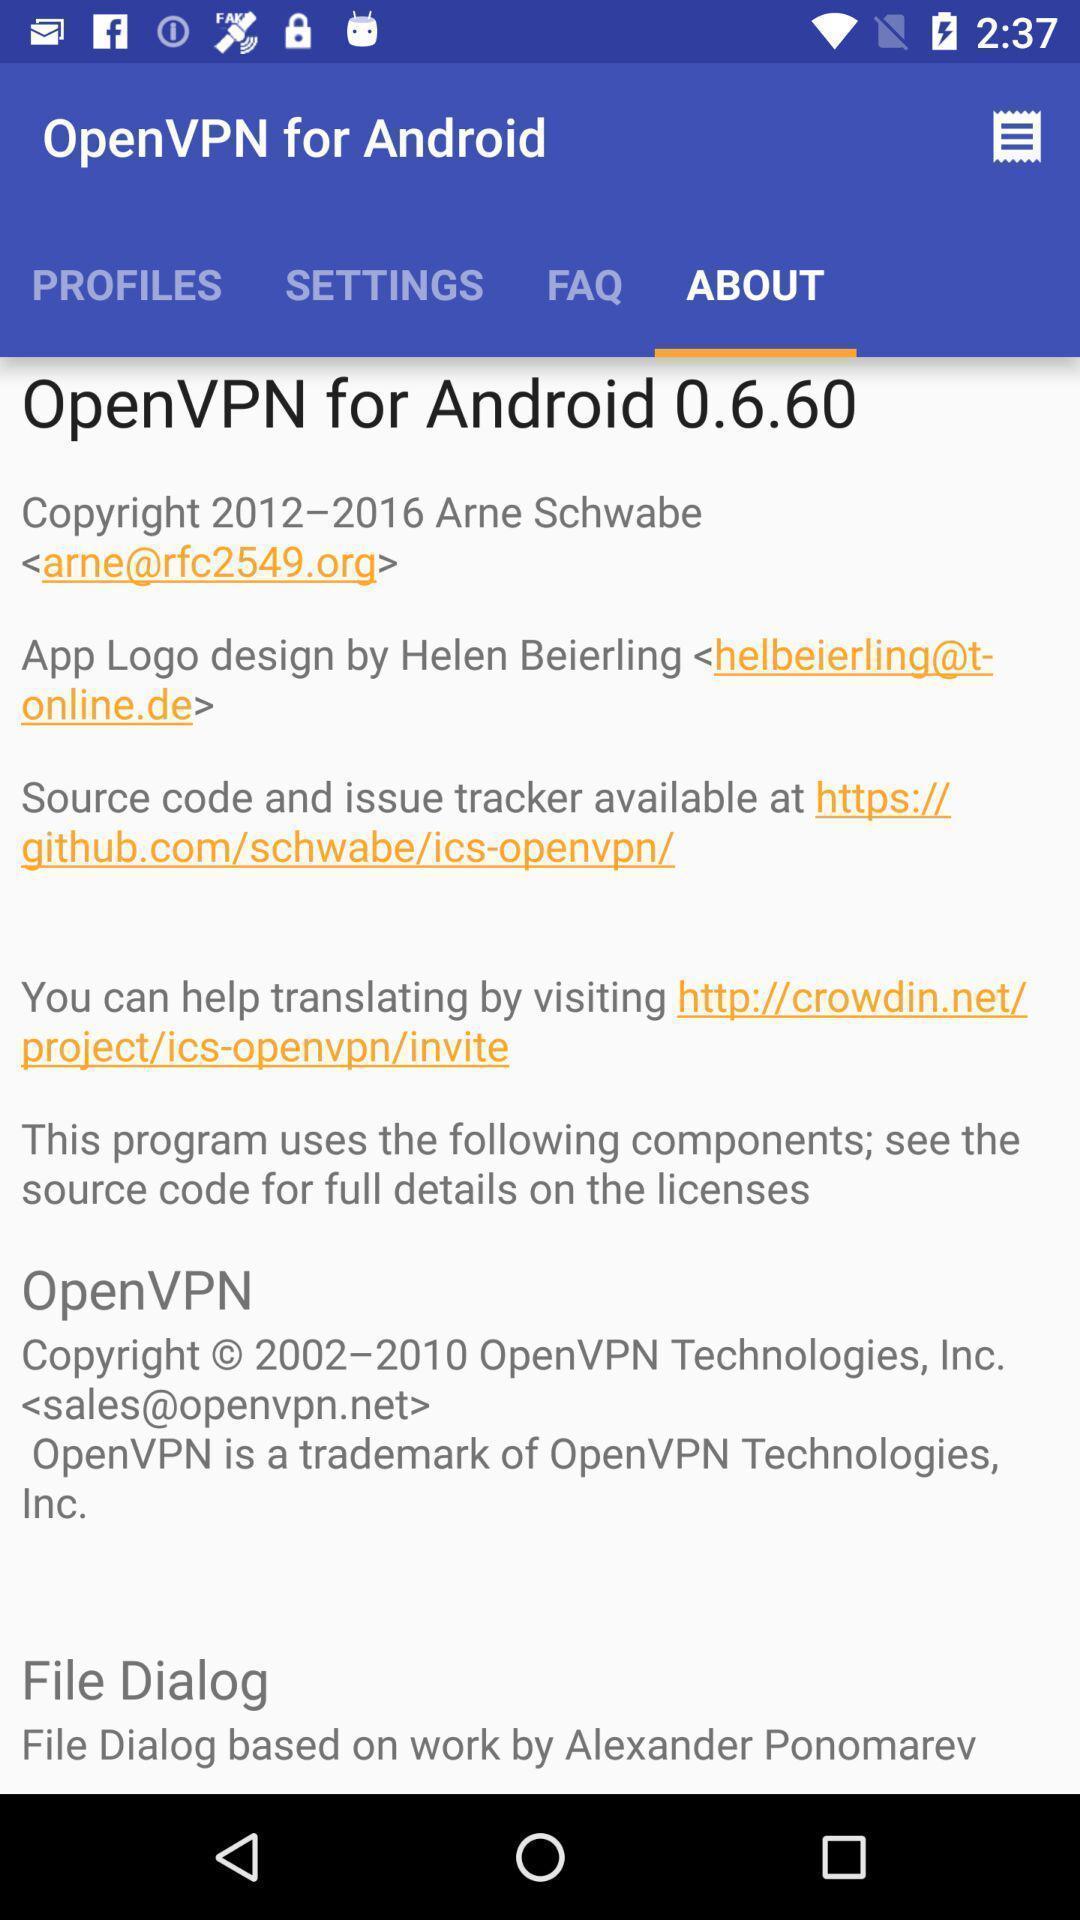Describe the content in this image. Screen page showing an information with different options. 